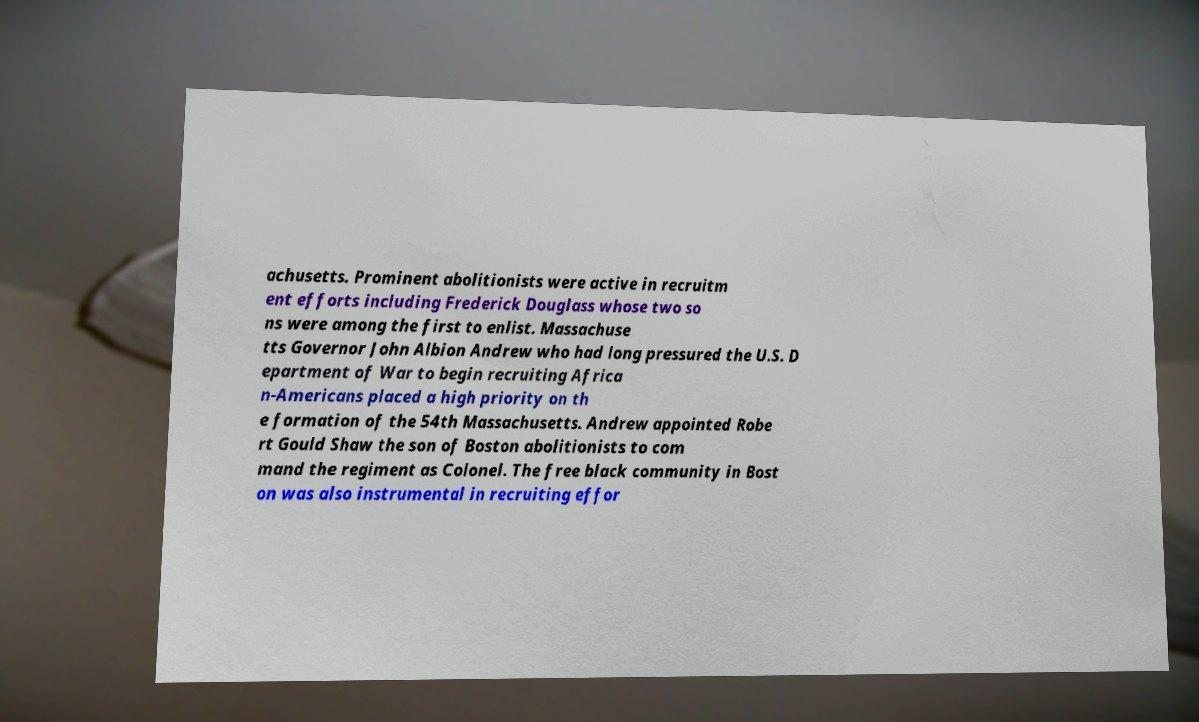I need the written content from this picture converted into text. Can you do that? achusetts. Prominent abolitionists were active in recruitm ent efforts including Frederick Douglass whose two so ns were among the first to enlist. Massachuse tts Governor John Albion Andrew who had long pressured the U.S. D epartment of War to begin recruiting Africa n-Americans placed a high priority on th e formation of the 54th Massachusetts. Andrew appointed Robe rt Gould Shaw the son of Boston abolitionists to com mand the regiment as Colonel. The free black community in Bost on was also instrumental in recruiting effor 